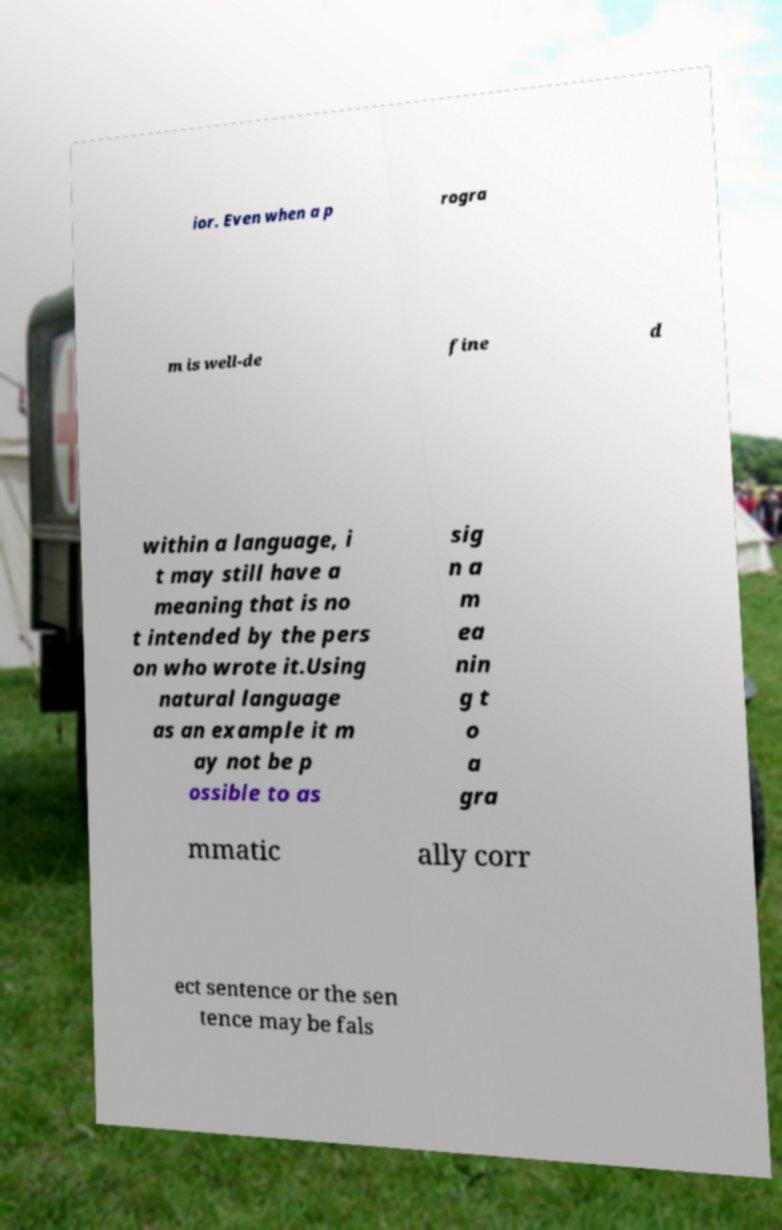Please identify and transcribe the text found in this image. ior. Even when a p rogra m is well-de fine d within a language, i t may still have a meaning that is no t intended by the pers on who wrote it.Using natural language as an example it m ay not be p ossible to as sig n a m ea nin g t o a gra mmatic ally corr ect sentence or the sen tence may be fals 